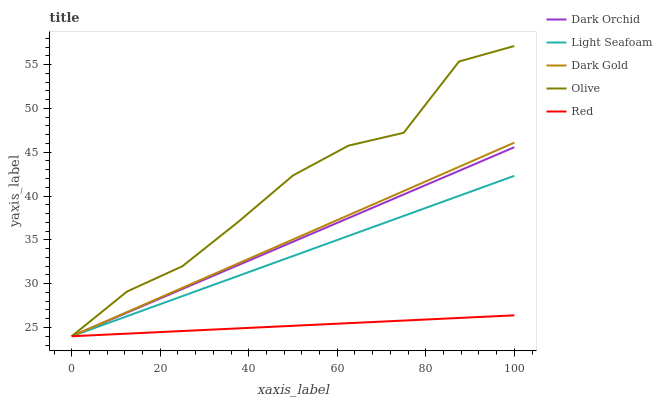Does Red have the minimum area under the curve?
Answer yes or no. Yes. Does Olive have the maximum area under the curve?
Answer yes or no. Yes. Does Light Seafoam have the minimum area under the curve?
Answer yes or no. No. Does Light Seafoam have the maximum area under the curve?
Answer yes or no. No. Is Red the smoothest?
Answer yes or no. Yes. Is Olive the roughest?
Answer yes or no. Yes. Is Light Seafoam the smoothest?
Answer yes or no. No. Is Light Seafoam the roughest?
Answer yes or no. No. Does Olive have the lowest value?
Answer yes or no. Yes. Does Olive have the highest value?
Answer yes or no. Yes. Does Light Seafoam have the highest value?
Answer yes or no. No. Does Light Seafoam intersect Dark Orchid?
Answer yes or no. Yes. Is Light Seafoam less than Dark Orchid?
Answer yes or no. No. Is Light Seafoam greater than Dark Orchid?
Answer yes or no. No. 